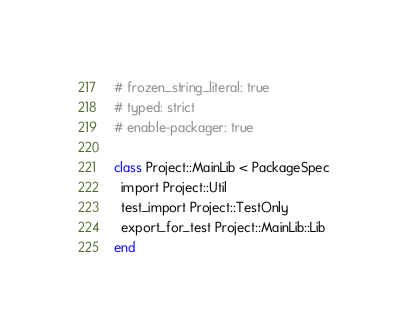<code> <loc_0><loc_0><loc_500><loc_500><_Ruby_># frozen_string_literal: true
# typed: strict
# enable-packager: true

class Project::MainLib < PackageSpec
  import Project::Util
  test_import Project::TestOnly
  export_for_test Project::MainLib::Lib
end
</code> 